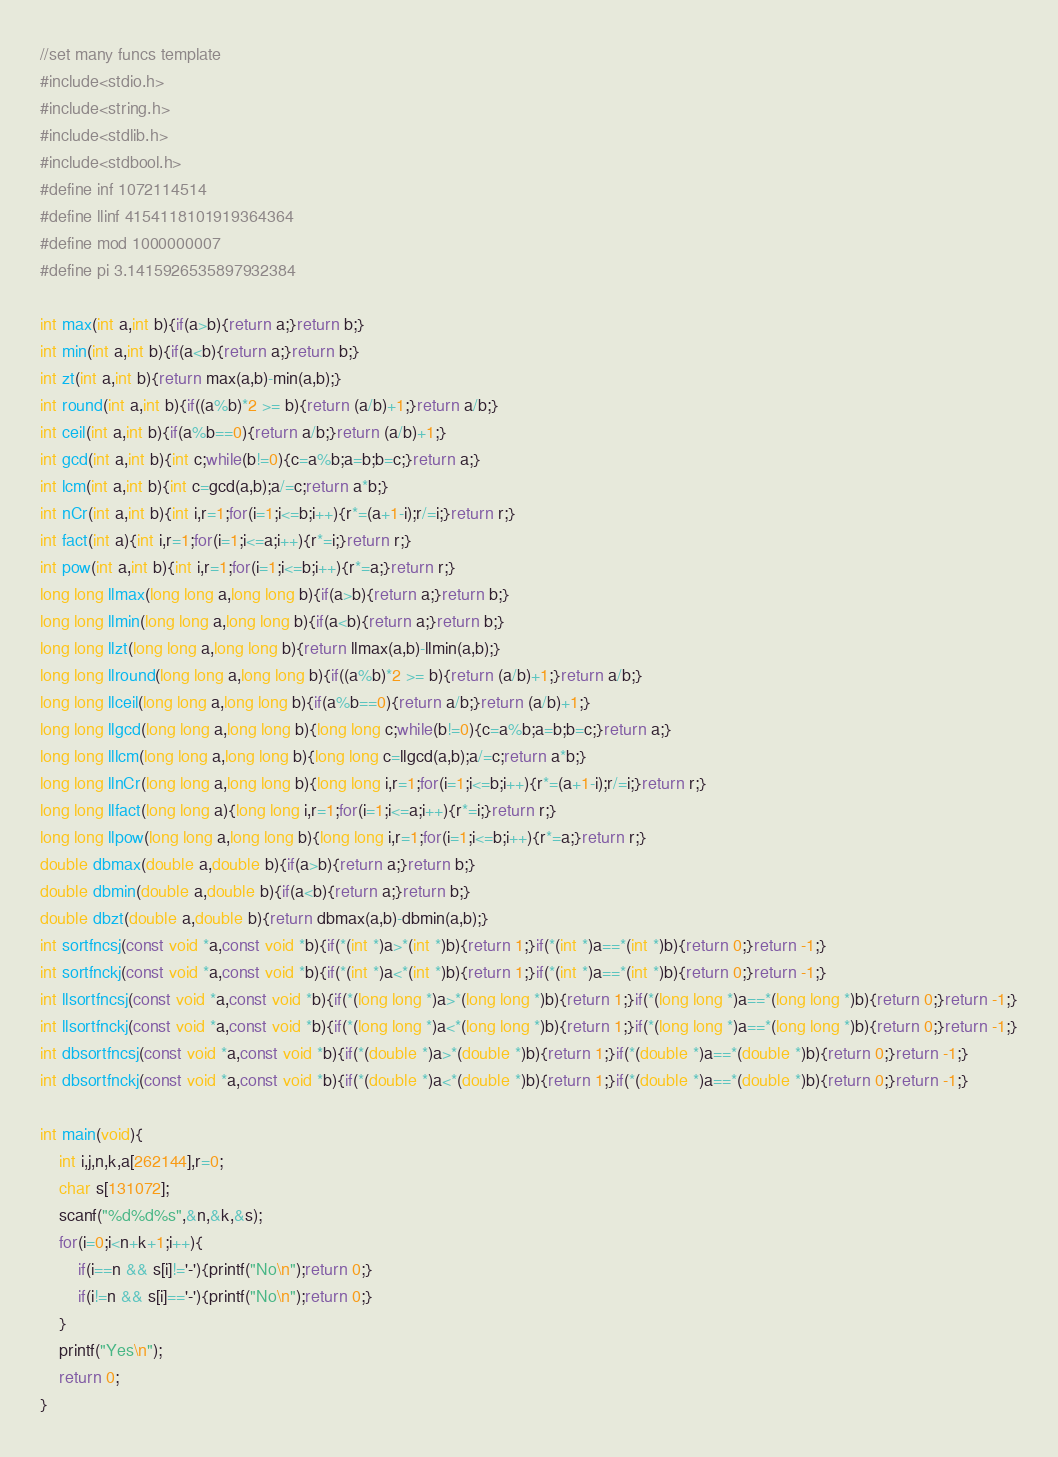<code> <loc_0><loc_0><loc_500><loc_500><_C_>//set many funcs template
#include<stdio.h>
#include<string.h>
#include<stdlib.h>
#include<stdbool.h>
#define inf 1072114514
#define llinf 4154118101919364364
#define mod 1000000007
#define pi 3.1415926535897932384

int max(int a,int b){if(a>b){return a;}return b;}
int min(int a,int b){if(a<b){return a;}return b;}
int zt(int a,int b){return max(a,b)-min(a,b);}
int round(int a,int b){if((a%b)*2 >= b){return (a/b)+1;}return a/b;}
int ceil(int a,int b){if(a%b==0){return a/b;}return (a/b)+1;}
int gcd(int a,int b){int c;while(b!=0){c=a%b;a=b;b=c;}return a;}
int lcm(int a,int b){int c=gcd(a,b);a/=c;return a*b;}
int nCr(int a,int b){int i,r=1;for(i=1;i<=b;i++){r*=(a+1-i);r/=i;}return r;}
int fact(int a){int i,r=1;for(i=1;i<=a;i++){r*=i;}return r;}
int pow(int a,int b){int i,r=1;for(i=1;i<=b;i++){r*=a;}return r;}
long long llmax(long long a,long long b){if(a>b){return a;}return b;}
long long llmin(long long a,long long b){if(a<b){return a;}return b;}
long long llzt(long long a,long long b){return llmax(a,b)-llmin(a,b);}
long long llround(long long a,long long b){if((a%b)*2 >= b){return (a/b)+1;}return a/b;}
long long llceil(long long a,long long b){if(a%b==0){return a/b;}return (a/b)+1;}
long long llgcd(long long a,long long b){long long c;while(b!=0){c=a%b;a=b;b=c;}return a;}
long long lllcm(long long a,long long b){long long c=llgcd(a,b);a/=c;return a*b;}
long long llnCr(long long a,long long b){long long i,r=1;for(i=1;i<=b;i++){r*=(a+1-i);r/=i;}return r;}
long long llfact(long long a){long long i,r=1;for(i=1;i<=a;i++){r*=i;}return r;}
long long llpow(long long a,long long b){long long i,r=1;for(i=1;i<=b;i++){r*=a;}return r;}
double dbmax(double a,double b){if(a>b){return a;}return b;}
double dbmin(double a,double b){if(a<b){return a;}return b;}
double dbzt(double a,double b){return dbmax(a,b)-dbmin(a,b);}
int sortfncsj(const void *a,const void *b){if(*(int *)a>*(int *)b){return 1;}if(*(int *)a==*(int *)b){return 0;}return -1;}
int sortfnckj(const void *a,const void *b){if(*(int *)a<*(int *)b){return 1;}if(*(int *)a==*(int *)b){return 0;}return -1;}
int llsortfncsj(const void *a,const void *b){if(*(long long *)a>*(long long *)b){return 1;}if(*(long long *)a==*(long long *)b){return 0;}return -1;}
int llsortfnckj(const void *a,const void *b){if(*(long long *)a<*(long long *)b){return 1;}if(*(long long *)a==*(long long *)b){return 0;}return -1;}
int dbsortfncsj(const void *a,const void *b){if(*(double *)a>*(double *)b){return 1;}if(*(double *)a==*(double *)b){return 0;}return -1;}
int dbsortfnckj(const void *a,const void *b){if(*(double *)a<*(double *)b){return 1;}if(*(double *)a==*(double *)b){return 0;}return -1;}

int main(void){
    int i,j,n,k,a[262144],r=0;
    char s[131072];
    scanf("%d%d%s",&n,&k,&s);
    for(i=0;i<n+k+1;i++){
        if(i==n && s[i]!='-'){printf("No\n");return 0;}
        if(i!=n && s[i]=='-'){printf("No\n");return 0;}
    }
    printf("Yes\n");
    return 0;
}</code> 